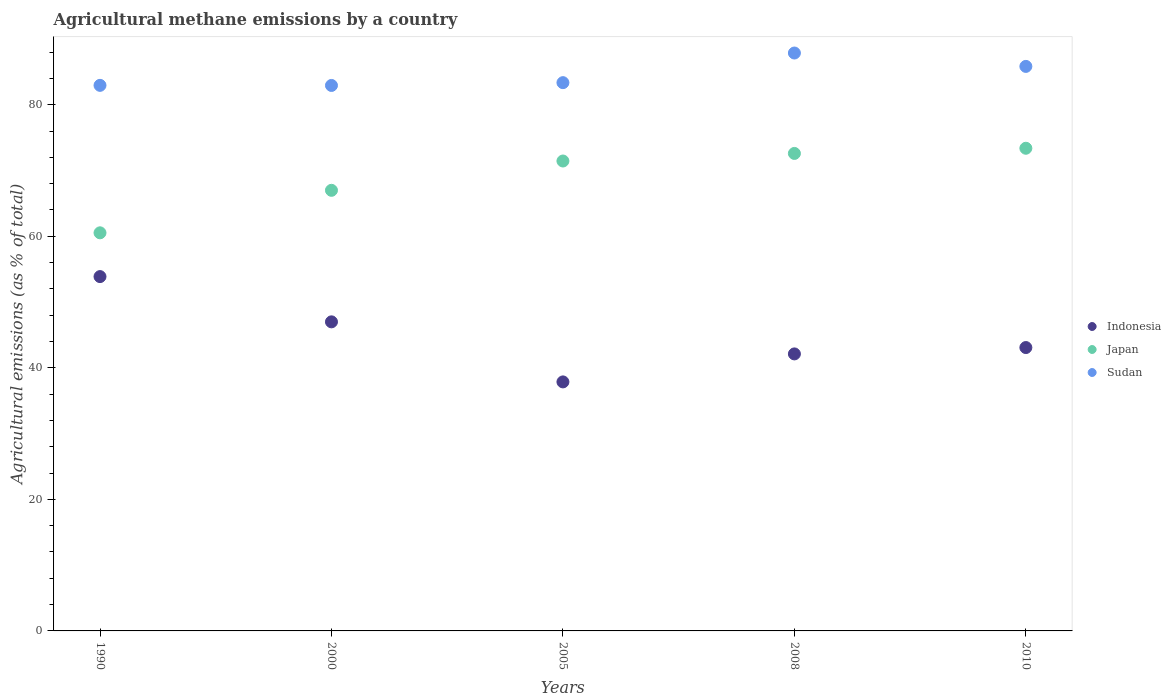How many different coloured dotlines are there?
Provide a succinct answer. 3. What is the amount of agricultural methane emitted in Indonesia in 1990?
Provide a short and direct response. 53.87. Across all years, what is the maximum amount of agricultural methane emitted in Sudan?
Offer a very short reply. 87.86. Across all years, what is the minimum amount of agricultural methane emitted in Japan?
Provide a succinct answer. 60.53. In which year was the amount of agricultural methane emitted in Indonesia maximum?
Make the answer very short. 1990. What is the total amount of agricultural methane emitted in Indonesia in the graph?
Offer a terse response. 223.92. What is the difference between the amount of agricultural methane emitted in Japan in 2000 and that in 2005?
Offer a terse response. -4.46. What is the difference between the amount of agricultural methane emitted in Indonesia in 2010 and the amount of agricultural methane emitted in Sudan in 2008?
Your answer should be compact. -44.78. What is the average amount of agricultural methane emitted in Indonesia per year?
Your answer should be compact. 44.78. In the year 2005, what is the difference between the amount of agricultural methane emitted in Indonesia and amount of agricultural methane emitted in Japan?
Keep it short and to the point. -33.58. In how many years, is the amount of agricultural methane emitted in Sudan greater than 52 %?
Your answer should be compact. 5. What is the ratio of the amount of agricultural methane emitted in Indonesia in 2000 to that in 2010?
Your answer should be compact. 1.09. Is the amount of agricultural methane emitted in Japan in 2000 less than that in 2008?
Ensure brevity in your answer.  Yes. Is the difference between the amount of agricultural methane emitted in Indonesia in 1990 and 2008 greater than the difference between the amount of agricultural methane emitted in Japan in 1990 and 2008?
Make the answer very short. Yes. What is the difference between the highest and the second highest amount of agricultural methane emitted in Indonesia?
Your answer should be compact. 6.88. What is the difference between the highest and the lowest amount of agricultural methane emitted in Japan?
Provide a short and direct response. 12.86. Is it the case that in every year, the sum of the amount of agricultural methane emitted in Sudan and amount of agricultural methane emitted in Indonesia  is greater than the amount of agricultural methane emitted in Japan?
Offer a very short reply. Yes. Does the amount of agricultural methane emitted in Japan monotonically increase over the years?
Provide a succinct answer. Yes. How many dotlines are there?
Ensure brevity in your answer.  3. How many years are there in the graph?
Offer a very short reply. 5. Does the graph contain any zero values?
Provide a succinct answer. No. Does the graph contain grids?
Keep it short and to the point. No. What is the title of the graph?
Provide a succinct answer. Agricultural methane emissions by a country. What is the label or title of the X-axis?
Your answer should be compact. Years. What is the label or title of the Y-axis?
Your answer should be compact. Agricultural emissions (as % of total). What is the Agricultural emissions (as % of total) in Indonesia in 1990?
Offer a terse response. 53.87. What is the Agricultural emissions (as % of total) of Japan in 1990?
Offer a terse response. 60.53. What is the Agricultural emissions (as % of total) in Sudan in 1990?
Give a very brief answer. 82.95. What is the Agricultural emissions (as % of total) in Indonesia in 2000?
Offer a terse response. 46.99. What is the Agricultural emissions (as % of total) of Japan in 2000?
Your answer should be compact. 66.99. What is the Agricultural emissions (as % of total) of Sudan in 2000?
Offer a very short reply. 82.93. What is the Agricultural emissions (as % of total) in Indonesia in 2005?
Make the answer very short. 37.86. What is the Agricultural emissions (as % of total) in Japan in 2005?
Offer a terse response. 71.44. What is the Agricultural emissions (as % of total) of Sudan in 2005?
Provide a succinct answer. 83.36. What is the Agricultural emissions (as % of total) of Indonesia in 2008?
Your answer should be very brief. 42.12. What is the Agricultural emissions (as % of total) in Japan in 2008?
Provide a short and direct response. 72.6. What is the Agricultural emissions (as % of total) in Sudan in 2008?
Provide a succinct answer. 87.86. What is the Agricultural emissions (as % of total) in Indonesia in 2010?
Offer a terse response. 43.08. What is the Agricultural emissions (as % of total) of Japan in 2010?
Offer a terse response. 73.38. What is the Agricultural emissions (as % of total) of Sudan in 2010?
Your answer should be very brief. 85.83. Across all years, what is the maximum Agricultural emissions (as % of total) of Indonesia?
Keep it short and to the point. 53.87. Across all years, what is the maximum Agricultural emissions (as % of total) in Japan?
Provide a short and direct response. 73.38. Across all years, what is the maximum Agricultural emissions (as % of total) in Sudan?
Make the answer very short. 87.86. Across all years, what is the minimum Agricultural emissions (as % of total) in Indonesia?
Ensure brevity in your answer.  37.86. Across all years, what is the minimum Agricultural emissions (as % of total) of Japan?
Give a very brief answer. 60.53. Across all years, what is the minimum Agricultural emissions (as % of total) of Sudan?
Provide a succinct answer. 82.93. What is the total Agricultural emissions (as % of total) of Indonesia in the graph?
Your response must be concise. 223.92. What is the total Agricultural emissions (as % of total) in Japan in the graph?
Make the answer very short. 344.94. What is the total Agricultural emissions (as % of total) of Sudan in the graph?
Give a very brief answer. 422.93. What is the difference between the Agricultural emissions (as % of total) of Indonesia in 1990 and that in 2000?
Your answer should be very brief. 6.88. What is the difference between the Agricultural emissions (as % of total) of Japan in 1990 and that in 2000?
Your answer should be compact. -6.46. What is the difference between the Agricultural emissions (as % of total) of Sudan in 1990 and that in 2000?
Keep it short and to the point. 0.01. What is the difference between the Agricultural emissions (as % of total) of Indonesia in 1990 and that in 2005?
Give a very brief answer. 16.01. What is the difference between the Agricultural emissions (as % of total) in Japan in 1990 and that in 2005?
Your answer should be very brief. -10.92. What is the difference between the Agricultural emissions (as % of total) of Sudan in 1990 and that in 2005?
Your answer should be compact. -0.41. What is the difference between the Agricultural emissions (as % of total) of Indonesia in 1990 and that in 2008?
Keep it short and to the point. 11.76. What is the difference between the Agricultural emissions (as % of total) of Japan in 1990 and that in 2008?
Your response must be concise. -12.07. What is the difference between the Agricultural emissions (as % of total) of Sudan in 1990 and that in 2008?
Provide a short and direct response. -4.92. What is the difference between the Agricultural emissions (as % of total) of Indonesia in 1990 and that in 2010?
Offer a very short reply. 10.79. What is the difference between the Agricultural emissions (as % of total) in Japan in 1990 and that in 2010?
Make the answer very short. -12.86. What is the difference between the Agricultural emissions (as % of total) in Sudan in 1990 and that in 2010?
Offer a very short reply. -2.88. What is the difference between the Agricultural emissions (as % of total) of Indonesia in 2000 and that in 2005?
Ensure brevity in your answer.  9.13. What is the difference between the Agricultural emissions (as % of total) in Japan in 2000 and that in 2005?
Your answer should be compact. -4.46. What is the difference between the Agricultural emissions (as % of total) of Sudan in 2000 and that in 2005?
Ensure brevity in your answer.  -0.43. What is the difference between the Agricultural emissions (as % of total) in Indonesia in 2000 and that in 2008?
Offer a very short reply. 4.87. What is the difference between the Agricultural emissions (as % of total) in Japan in 2000 and that in 2008?
Offer a terse response. -5.61. What is the difference between the Agricultural emissions (as % of total) in Sudan in 2000 and that in 2008?
Offer a terse response. -4.93. What is the difference between the Agricultural emissions (as % of total) of Indonesia in 2000 and that in 2010?
Keep it short and to the point. 3.91. What is the difference between the Agricultural emissions (as % of total) in Japan in 2000 and that in 2010?
Offer a terse response. -6.39. What is the difference between the Agricultural emissions (as % of total) of Sudan in 2000 and that in 2010?
Offer a terse response. -2.9. What is the difference between the Agricultural emissions (as % of total) in Indonesia in 2005 and that in 2008?
Your answer should be compact. -4.26. What is the difference between the Agricultural emissions (as % of total) of Japan in 2005 and that in 2008?
Provide a succinct answer. -1.15. What is the difference between the Agricultural emissions (as % of total) in Sudan in 2005 and that in 2008?
Make the answer very short. -4.51. What is the difference between the Agricultural emissions (as % of total) of Indonesia in 2005 and that in 2010?
Offer a terse response. -5.22. What is the difference between the Agricultural emissions (as % of total) in Japan in 2005 and that in 2010?
Your answer should be compact. -1.94. What is the difference between the Agricultural emissions (as % of total) in Sudan in 2005 and that in 2010?
Offer a terse response. -2.47. What is the difference between the Agricultural emissions (as % of total) in Indonesia in 2008 and that in 2010?
Give a very brief answer. -0.97. What is the difference between the Agricultural emissions (as % of total) in Japan in 2008 and that in 2010?
Your response must be concise. -0.79. What is the difference between the Agricultural emissions (as % of total) of Sudan in 2008 and that in 2010?
Make the answer very short. 2.03. What is the difference between the Agricultural emissions (as % of total) in Indonesia in 1990 and the Agricultural emissions (as % of total) in Japan in 2000?
Ensure brevity in your answer.  -13.12. What is the difference between the Agricultural emissions (as % of total) in Indonesia in 1990 and the Agricultural emissions (as % of total) in Sudan in 2000?
Keep it short and to the point. -29.06. What is the difference between the Agricultural emissions (as % of total) in Japan in 1990 and the Agricultural emissions (as % of total) in Sudan in 2000?
Your answer should be compact. -22.4. What is the difference between the Agricultural emissions (as % of total) in Indonesia in 1990 and the Agricultural emissions (as % of total) in Japan in 2005?
Your response must be concise. -17.57. What is the difference between the Agricultural emissions (as % of total) of Indonesia in 1990 and the Agricultural emissions (as % of total) of Sudan in 2005?
Your answer should be very brief. -29.49. What is the difference between the Agricultural emissions (as % of total) in Japan in 1990 and the Agricultural emissions (as % of total) in Sudan in 2005?
Provide a short and direct response. -22.83. What is the difference between the Agricultural emissions (as % of total) of Indonesia in 1990 and the Agricultural emissions (as % of total) of Japan in 2008?
Keep it short and to the point. -18.73. What is the difference between the Agricultural emissions (as % of total) in Indonesia in 1990 and the Agricultural emissions (as % of total) in Sudan in 2008?
Provide a short and direct response. -33.99. What is the difference between the Agricultural emissions (as % of total) of Japan in 1990 and the Agricultural emissions (as % of total) of Sudan in 2008?
Offer a very short reply. -27.34. What is the difference between the Agricultural emissions (as % of total) in Indonesia in 1990 and the Agricultural emissions (as % of total) in Japan in 2010?
Provide a succinct answer. -19.51. What is the difference between the Agricultural emissions (as % of total) of Indonesia in 1990 and the Agricultural emissions (as % of total) of Sudan in 2010?
Make the answer very short. -31.96. What is the difference between the Agricultural emissions (as % of total) in Japan in 1990 and the Agricultural emissions (as % of total) in Sudan in 2010?
Provide a short and direct response. -25.3. What is the difference between the Agricultural emissions (as % of total) in Indonesia in 2000 and the Agricultural emissions (as % of total) in Japan in 2005?
Give a very brief answer. -24.45. What is the difference between the Agricultural emissions (as % of total) in Indonesia in 2000 and the Agricultural emissions (as % of total) in Sudan in 2005?
Your answer should be very brief. -36.37. What is the difference between the Agricultural emissions (as % of total) in Japan in 2000 and the Agricultural emissions (as % of total) in Sudan in 2005?
Your response must be concise. -16.37. What is the difference between the Agricultural emissions (as % of total) of Indonesia in 2000 and the Agricultural emissions (as % of total) of Japan in 2008?
Provide a succinct answer. -25.61. What is the difference between the Agricultural emissions (as % of total) in Indonesia in 2000 and the Agricultural emissions (as % of total) in Sudan in 2008?
Keep it short and to the point. -40.87. What is the difference between the Agricultural emissions (as % of total) of Japan in 2000 and the Agricultural emissions (as % of total) of Sudan in 2008?
Offer a very short reply. -20.87. What is the difference between the Agricultural emissions (as % of total) of Indonesia in 2000 and the Agricultural emissions (as % of total) of Japan in 2010?
Your answer should be compact. -26.39. What is the difference between the Agricultural emissions (as % of total) of Indonesia in 2000 and the Agricultural emissions (as % of total) of Sudan in 2010?
Your response must be concise. -38.84. What is the difference between the Agricultural emissions (as % of total) in Japan in 2000 and the Agricultural emissions (as % of total) in Sudan in 2010?
Your answer should be very brief. -18.84. What is the difference between the Agricultural emissions (as % of total) in Indonesia in 2005 and the Agricultural emissions (as % of total) in Japan in 2008?
Ensure brevity in your answer.  -34.74. What is the difference between the Agricultural emissions (as % of total) of Indonesia in 2005 and the Agricultural emissions (as % of total) of Sudan in 2008?
Your response must be concise. -50. What is the difference between the Agricultural emissions (as % of total) of Japan in 2005 and the Agricultural emissions (as % of total) of Sudan in 2008?
Provide a short and direct response. -16.42. What is the difference between the Agricultural emissions (as % of total) of Indonesia in 2005 and the Agricultural emissions (as % of total) of Japan in 2010?
Give a very brief answer. -35.52. What is the difference between the Agricultural emissions (as % of total) of Indonesia in 2005 and the Agricultural emissions (as % of total) of Sudan in 2010?
Keep it short and to the point. -47.97. What is the difference between the Agricultural emissions (as % of total) in Japan in 2005 and the Agricultural emissions (as % of total) in Sudan in 2010?
Make the answer very short. -14.38. What is the difference between the Agricultural emissions (as % of total) of Indonesia in 2008 and the Agricultural emissions (as % of total) of Japan in 2010?
Offer a terse response. -31.27. What is the difference between the Agricultural emissions (as % of total) of Indonesia in 2008 and the Agricultural emissions (as % of total) of Sudan in 2010?
Ensure brevity in your answer.  -43.71. What is the difference between the Agricultural emissions (as % of total) of Japan in 2008 and the Agricultural emissions (as % of total) of Sudan in 2010?
Ensure brevity in your answer.  -13.23. What is the average Agricultural emissions (as % of total) of Indonesia per year?
Your answer should be very brief. 44.78. What is the average Agricultural emissions (as % of total) of Japan per year?
Provide a succinct answer. 68.99. What is the average Agricultural emissions (as % of total) in Sudan per year?
Your answer should be very brief. 84.59. In the year 1990, what is the difference between the Agricultural emissions (as % of total) in Indonesia and Agricultural emissions (as % of total) in Japan?
Your answer should be compact. -6.66. In the year 1990, what is the difference between the Agricultural emissions (as % of total) in Indonesia and Agricultural emissions (as % of total) in Sudan?
Offer a very short reply. -29.08. In the year 1990, what is the difference between the Agricultural emissions (as % of total) of Japan and Agricultural emissions (as % of total) of Sudan?
Provide a short and direct response. -22.42. In the year 2000, what is the difference between the Agricultural emissions (as % of total) in Indonesia and Agricultural emissions (as % of total) in Japan?
Provide a succinct answer. -20. In the year 2000, what is the difference between the Agricultural emissions (as % of total) in Indonesia and Agricultural emissions (as % of total) in Sudan?
Ensure brevity in your answer.  -35.94. In the year 2000, what is the difference between the Agricultural emissions (as % of total) in Japan and Agricultural emissions (as % of total) in Sudan?
Give a very brief answer. -15.94. In the year 2005, what is the difference between the Agricultural emissions (as % of total) in Indonesia and Agricultural emissions (as % of total) in Japan?
Offer a very short reply. -33.58. In the year 2005, what is the difference between the Agricultural emissions (as % of total) of Indonesia and Agricultural emissions (as % of total) of Sudan?
Provide a short and direct response. -45.5. In the year 2005, what is the difference between the Agricultural emissions (as % of total) of Japan and Agricultural emissions (as % of total) of Sudan?
Your response must be concise. -11.91. In the year 2008, what is the difference between the Agricultural emissions (as % of total) in Indonesia and Agricultural emissions (as % of total) in Japan?
Offer a very short reply. -30.48. In the year 2008, what is the difference between the Agricultural emissions (as % of total) in Indonesia and Agricultural emissions (as % of total) in Sudan?
Keep it short and to the point. -45.75. In the year 2008, what is the difference between the Agricultural emissions (as % of total) in Japan and Agricultural emissions (as % of total) in Sudan?
Your answer should be compact. -15.27. In the year 2010, what is the difference between the Agricultural emissions (as % of total) in Indonesia and Agricultural emissions (as % of total) in Japan?
Your answer should be compact. -30.3. In the year 2010, what is the difference between the Agricultural emissions (as % of total) in Indonesia and Agricultural emissions (as % of total) in Sudan?
Make the answer very short. -42.75. In the year 2010, what is the difference between the Agricultural emissions (as % of total) of Japan and Agricultural emissions (as % of total) of Sudan?
Your answer should be compact. -12.45. What is the ratio of the Agricultural emissions (as % of total) in Indonesia in 1990 to that in 2000?
Give a very brief answer. 1.15. What is the ratio of the Agricultural emissions (as % of total) of Japan in 1990 to that in 2000?
Your response must be concise. 0.9. What is the ratio of the Agricultural emissions (as % of total) in Sudan in 1990 to that in 2000?
Your answer should be compact. 1. What is the ratio of the Agricultural emissions (as % of total) of Indonesia in 1990 to that in 2005?
Keep it short and to the point. 1.42. What is the ratio of the Agricultural emissions (as % of total) of Japan in 1990 to that in 2005?
Give a very brief answer. 0.85. What is the ratio of the Agricultural emissions (as % of total) of Sudan in 1990 to that in 2005?
Provide a short and direct response. 1. What is the ratio of the Agricultural emissions (as % of total) of Indonesia in 1990 to that in 2008?
Your response must be concise. 1.28. What is the ratio of the Agricultural emissions (as % of total) of Japan in 1990 to that in 2008?
Your response must be concise. 0.83. What is the ratio of the Agricultural emissions (as % of total) in Sudan in 1990 to that in 2008?
Make the answer very short. 0.94. What is the ratio of the Agricultural emissions (as % of total) of Indonesia in 1990 to that in 2010?
Ensure brevity in your answer.  1.25. What is the ratio of the Agricultural emissions (as % of total) of Japan in 1990 to that in 2010?
Provide a succinct answer. 0.82. What is the ratio of the Agricultural emissions (as % of total) of Sudan in 1990 to that in 2010?
Your answer should be very brief. 0.97. What is the ratio of the Agricultural emissions (as % of total) in Indonesia in 2000 to that in 2005?
Provide a short and direct response. 1.24. What is the ratio of the Agricultural emissions (as % of total) of Japan in 2000 to that in 2005?
Offer a very short reply. 0.94. What is the ratio of the Agricultural emissions (as % of total) in Indonesia in 2000 to that in 2008?
Give a very brief answer. 1.12. What is the ratio of the Agricultural emissions (as % of total) of Japan in 2000 to that in 2008?
Provide a succinct answer. 0.92. What is the ratio of the Agricultural emissions (as % of total) in Sudan in 2000 to that in 2008?
Keep it short and to the point. 0.94. What is the ratio of the Agricultural emissions (as % of total) of Indonesia in 2000 to that in 2010?
Your answer should be compact. 1.09. What is the ratio of the Agricultural emissions (as % of total) of Japan in 2000 to that in 2010?
Ensure brevity in your answer.  0.91. What is the ratio of the Agricultural emissions (as % of total) in Sudan in 2000 to that in 2010?
Offer a very short reply. 0.97. What is the ratio of the Agricultural emissions (as % of total) in Indonesia in 2005 to that in 2008?
Keep it short and to the point. 0.9. What is the ratio of the Agricultural emissions (as % of total) in Japan in 2005 to that in 2008?
Your answer should be very brief. 0.98. What is the ratio of the Agricultural emissions (as % of total) of Sudan in 2005 to that in 2008?
Your answer should be very brief. 0.95. What is the ratio of the Agricultural emissions (as % of total) of Indonesia in 2005 to that in 2010?
Make the answer very short. 0.88. What is the ratio of the Agricultural emissions (as % of total) in Japan in 2005 to that in 2010?
Provide a short and direct response. 0.97. What is the ratio of the Agricultural emissions (as % of total) of Sudan in 2005 to that in 2010?
Your answer should be compact. 0.97. What is the ratio of the Agricultural emissions (as % of total) of Indonesia in 2008 to that in 2010?
Provide a short and direct response. 0.98. What is the ratio of the Agricultural emissions (as % of total) in Japan in 2008 to that in 2010?
Keep it short and to the point. 0.99. What is the ratio of the Agricultural emissions (as % of total) of Sudan in 2008 to that in 2010?
Provide a succinct answer. 1.02. What is the difference between the highest and the second highest Agricultural emissions (as % of total) of Indonesia?
Offer a terse response. 6.88. What is the difference between the highest and the second highest Agricultural emissions (as % of total) of Japan?
Offer a terse response. 0.79. What is the difference between the highest and the second highest Agricultural emissions (as % of total) of Sudan?
Keep it short and to the point. 2.03. What is the difference between the highest and the lowest Agricultural emissions (as % of total) of Indonesia?
Make the answer very short. 16.01. What is the difference between the highest and the lowest Agricultural emissions (as % of total) of Japan?
Keep it short and to the point. 12.86. What is the difference between the highest and the lowest Agricultural emissions (as % of total) in Sudan?
Your response must be concise. 4.93. 